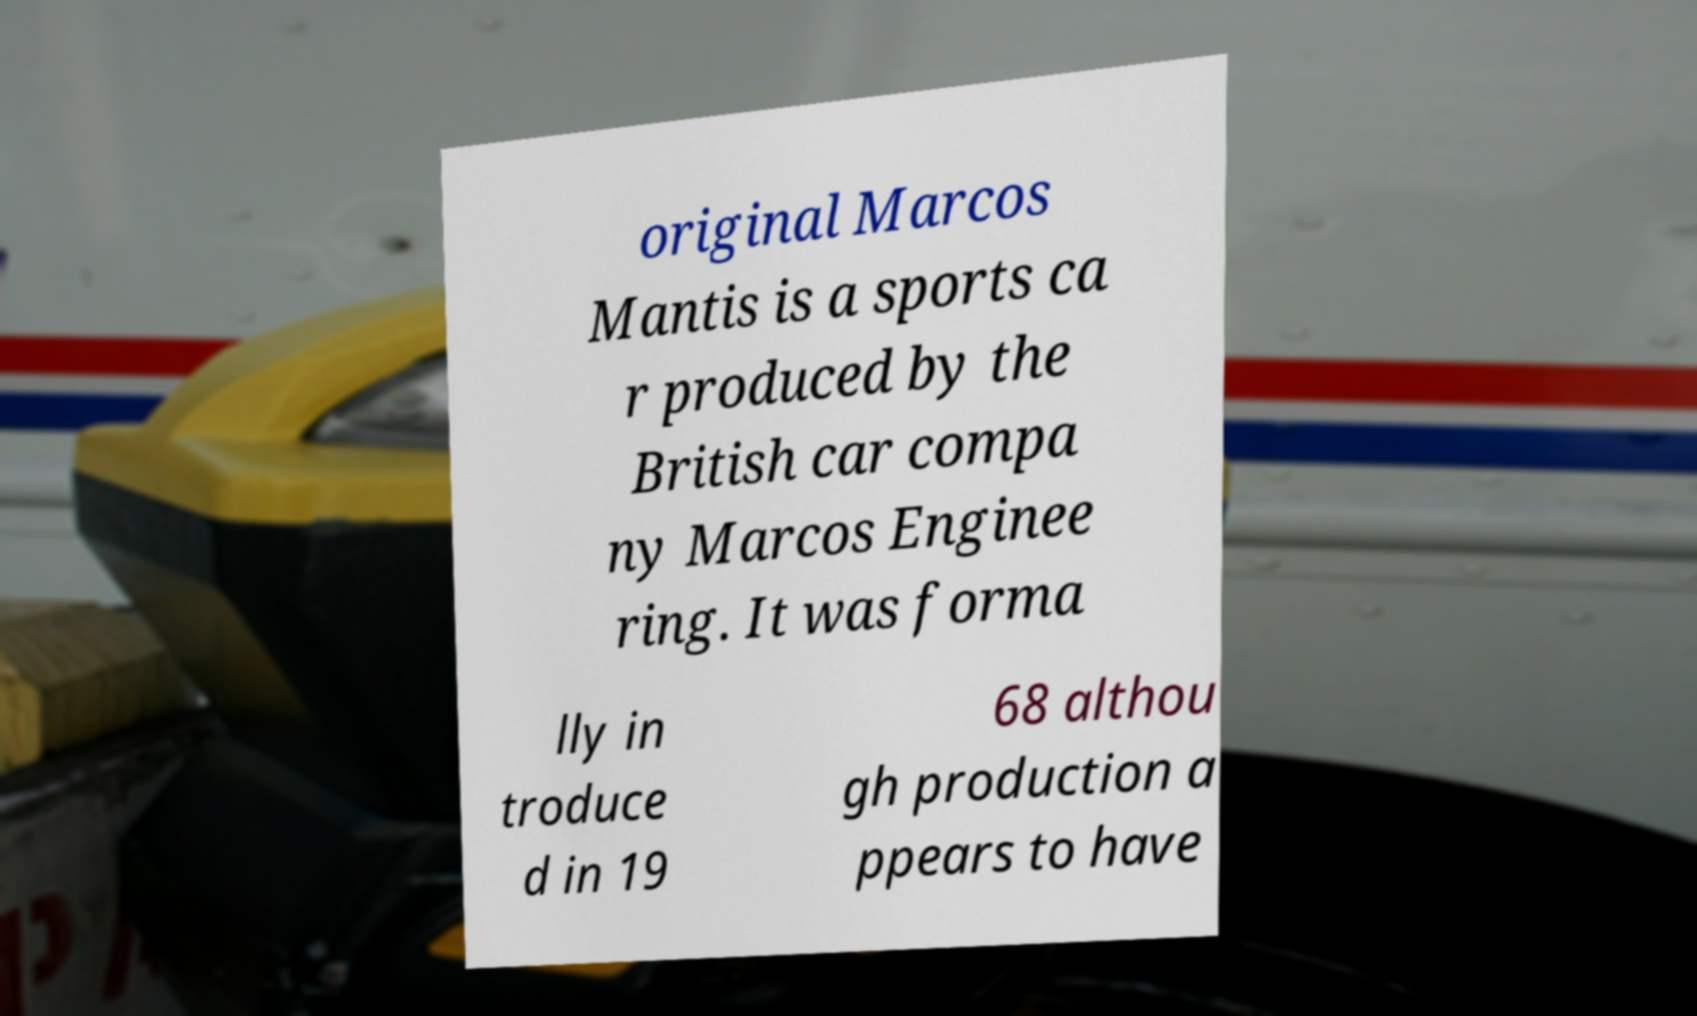Could you assist in decoding the text presented in this image and type it out clearly? original Marcos Mantis is a sports ca r produced by the British car compa ny Marcos Enginee ring. It was forma lly in troduce d in 19 68 althou gh production a ppears to have 